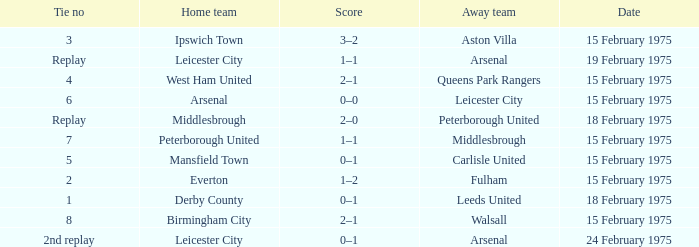What was the date when the away team was the leeds united? 18 February 1975. 